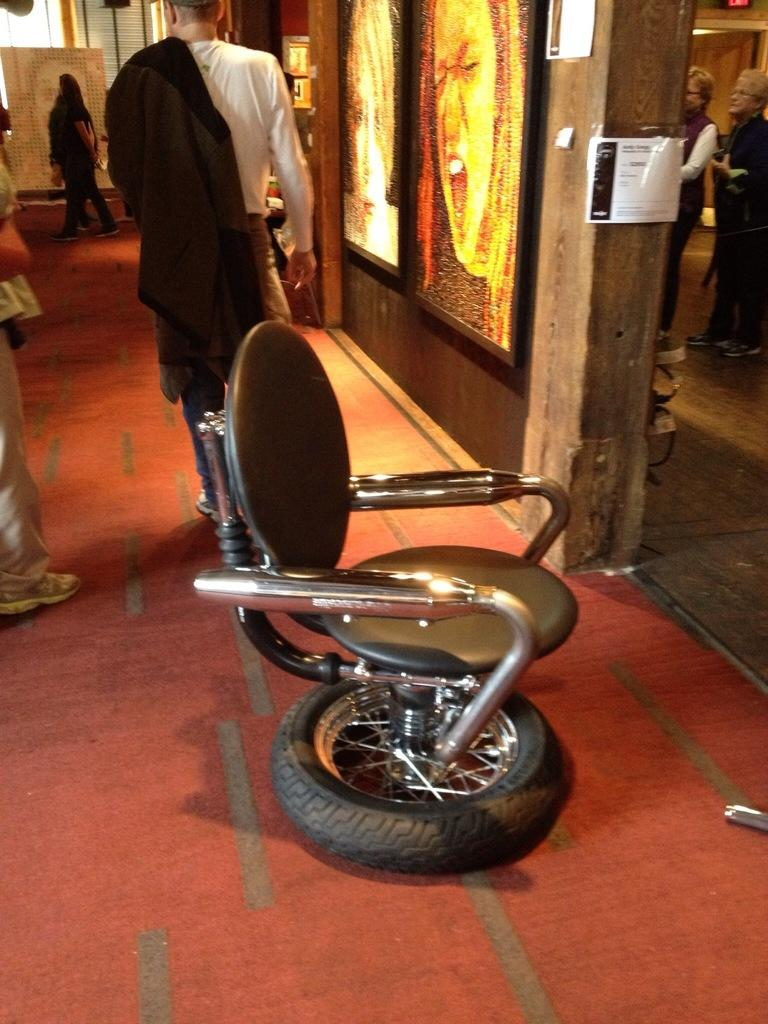What type of furniture is present in the image? There is a chair in the image. What can be seen happening in the background of the image? There are people walking in the background of the image. Where are the photo frames located in the image? The photo frames are on the right side of the image. What type of competition is taking place in the image? There is no competition present in the image. What scent can be smelled coming from the chair in the image? There is no mention of any scent in the image, as it is a visual medium. 